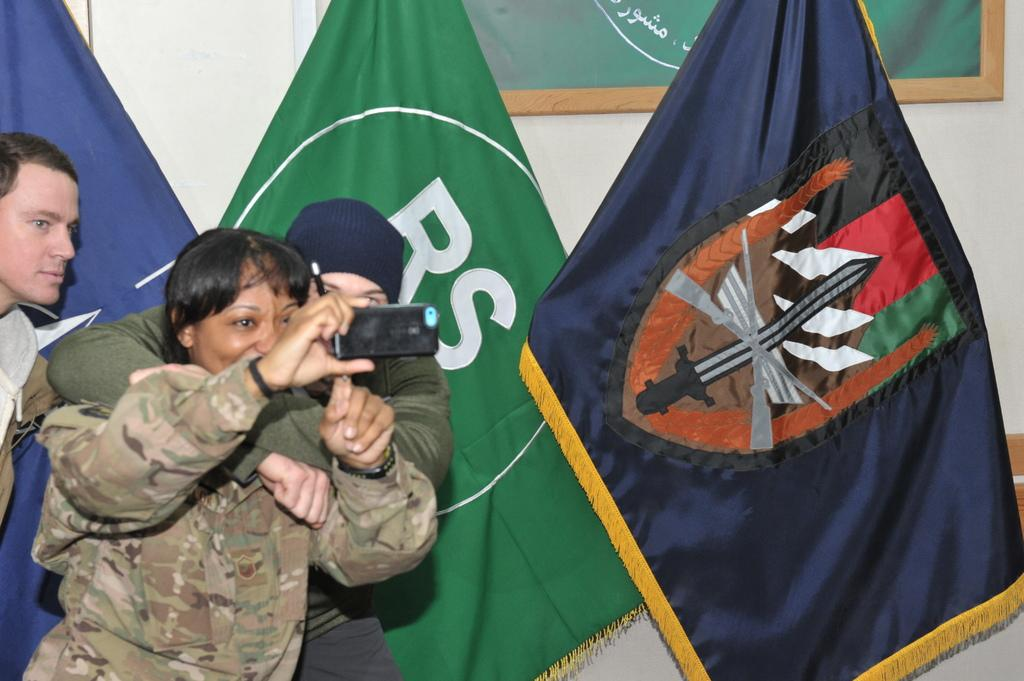How many people are in the image? There are people in the image, but the exact number is not specified. What is one person holding in the image? One person is holding a mobile in the image. What is another person holding in the image? Another person is holding a pen in the image. What can be seen in the background of the image? There are flags and a board on a wall in the background of the image. What type of plantation can be seen in the image? There is no plantation present in the image. Can you see an owl in the image? There is no owl present in the image. Is there a goldfish visible in the image? There is no goldfish present in the image. 